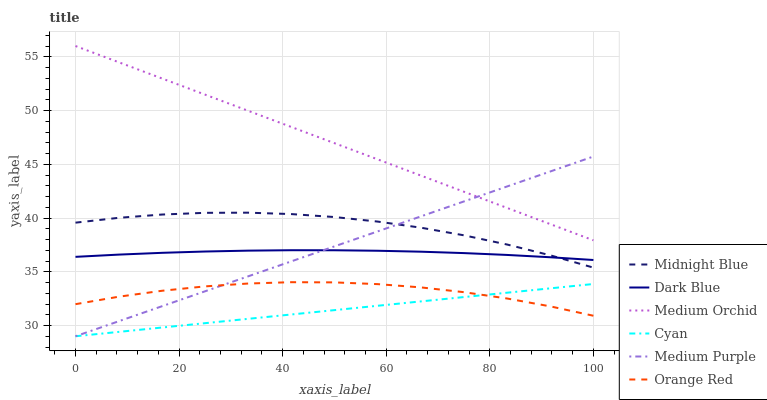Does Cyan have the minimum area under the curve?
Answer yes or no. Yes. Does Medium Orchid have the maximum area under the curve?
Answer yes or no. Yes. Does Medium Purple have the minimum area under the curve?
Answer yes or no. No. Does Medium Purple have the maximum area under the curve?
Answer yes or no. No. Is Cyan the smoothest?
Answer yes or no. Yes. Is Midnight Blue the roughest?
Answer yes or no. Yes. Is Medium Orchid the smoothest?
Answer yes or no. No. Is Medium Orchid the roughest?
Answer yes or no. No. Does Medium Purple have the lowest value?
Answer yes or no. Yes. Does Medium Orchid have the lowest value?
Answer yes or no. No. Does Medium Orchid have the highest value?
Answer yes or no. Yes. Does Medium Purple have the highest value?
Answer yes or no. No. Is Orange Red less than Dark Blue?
Answer yes or no. Yes. Is Dark Blue greater than Cyan?
Answer yes or no. Yes. Does Orange Red intersect Cyan?
Answer yes or no. Yes. Is Orange Red less than Cyan?
Answer yes or no. No. Is Orange Red greater than Cyan?
Answer yes or no. No. Does Orange Red intersect Dark Blue?
Answer yes or no. No. 